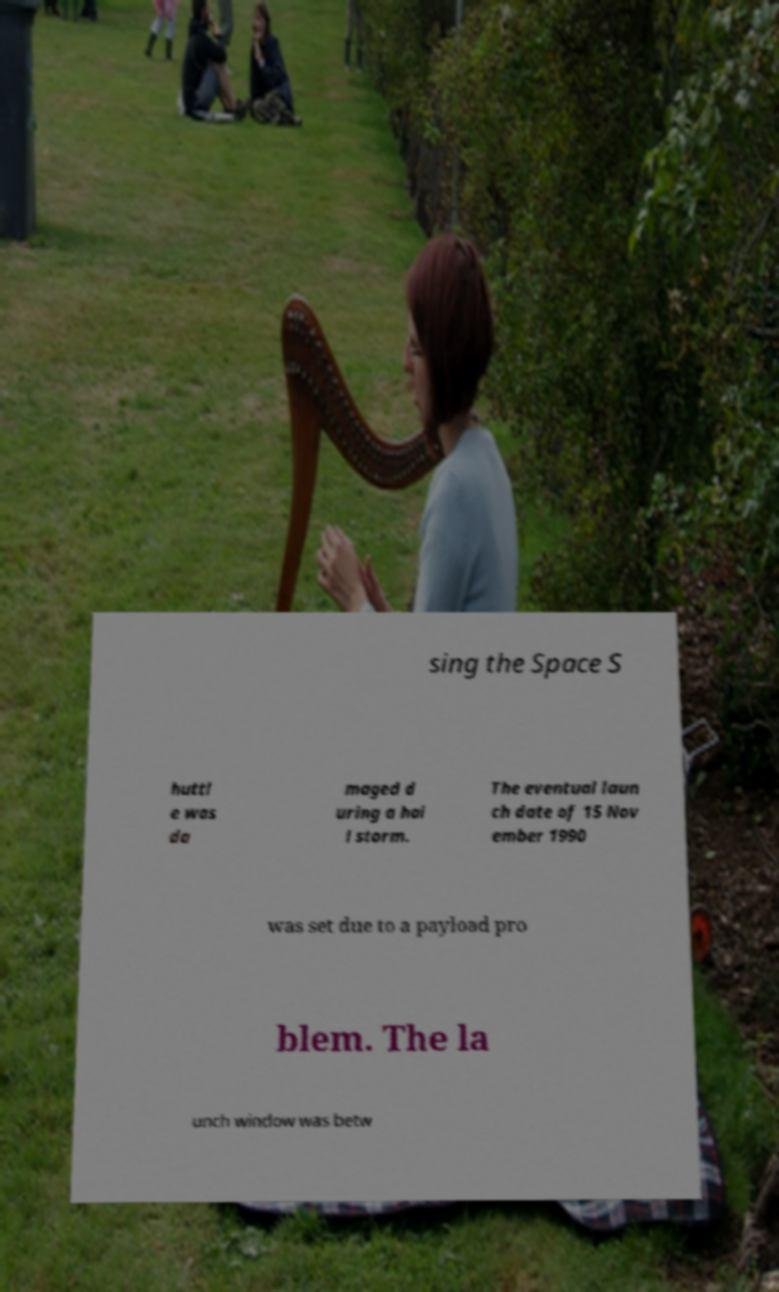Could you extract and type out the text from this image? sing the Space S huttl e was da maged d uring a hai l storm. The eventual laun ch date of 15 Nov ember 1990 was set due to a payload pro blem. The la unch window was betw 